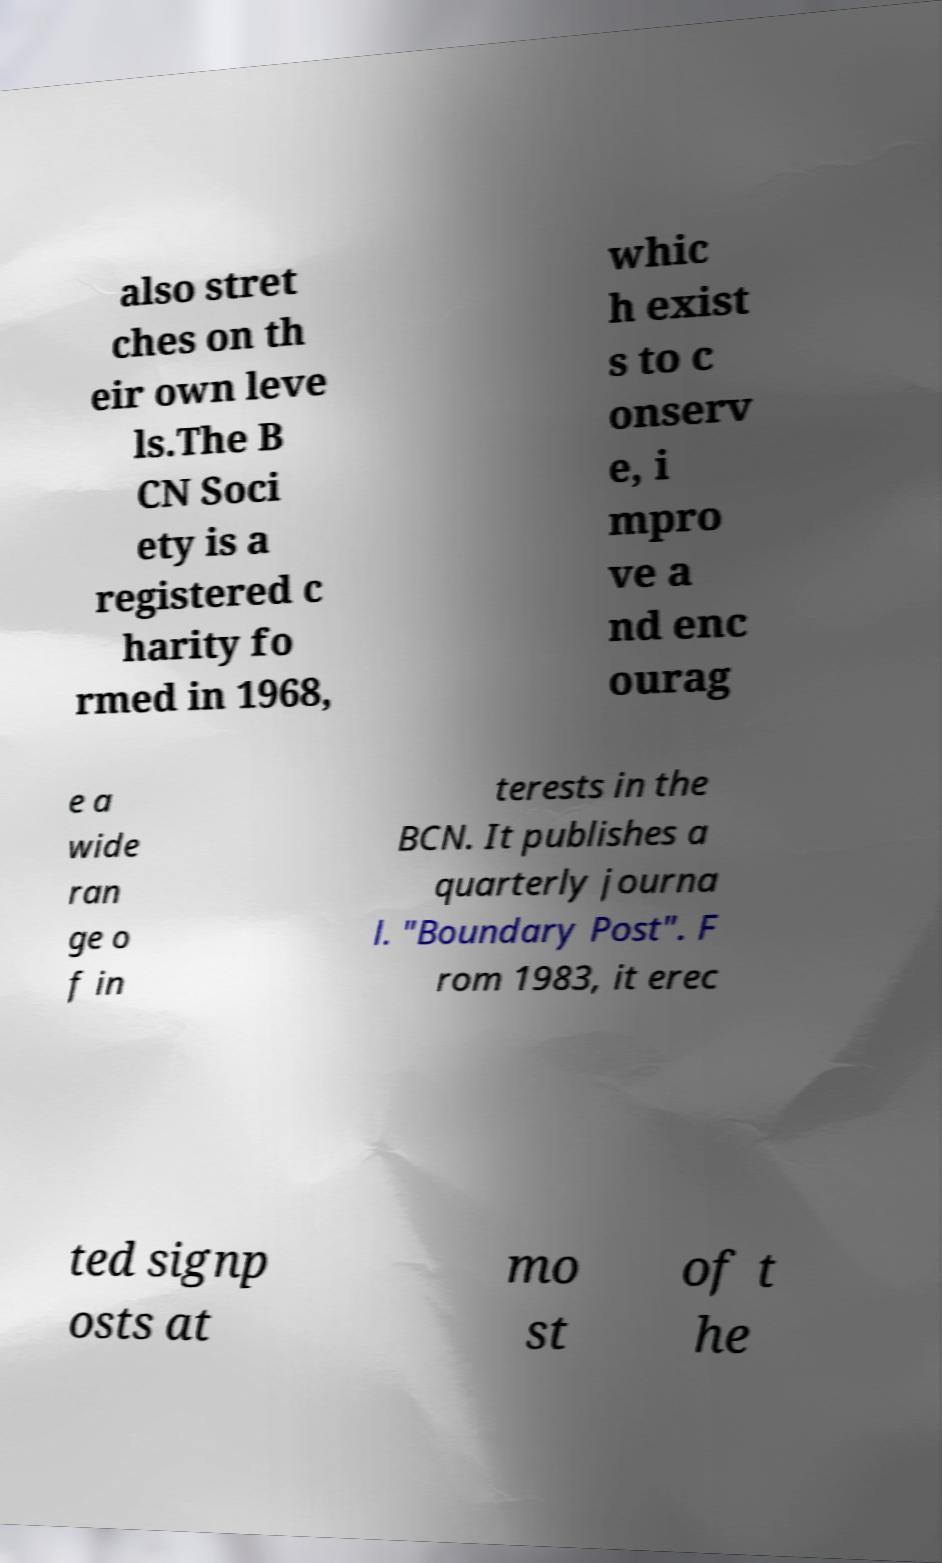For documentation purposes, I need the text within this image transcribed. Could you provide that? also stret ches on th eir own leve ls.The B CN Soci ety is a registered c harity fo rmed in 1968, whic h exist s to c onserv e, i mpro ve a nd enc ourag e a wide ran ge o f in terests in the BCN. It publishes a quarterly journa l. "Boundary Post". F rom 1983, it erec ted signp osts at mo st of t he 